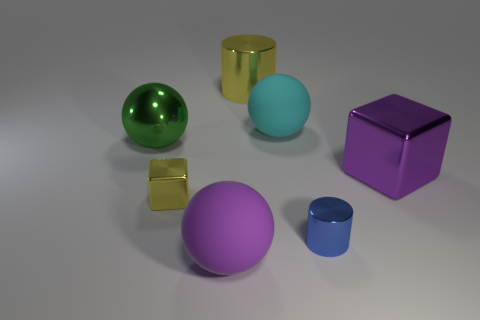How many small blue metallic things are behind the shiny cube that is on the right side of the tiny blue metal cylinder? Upon careful observation, it appears that there are no small blue metallic objects located behind the shiny cube to the right of the small blue metal cylinder. 